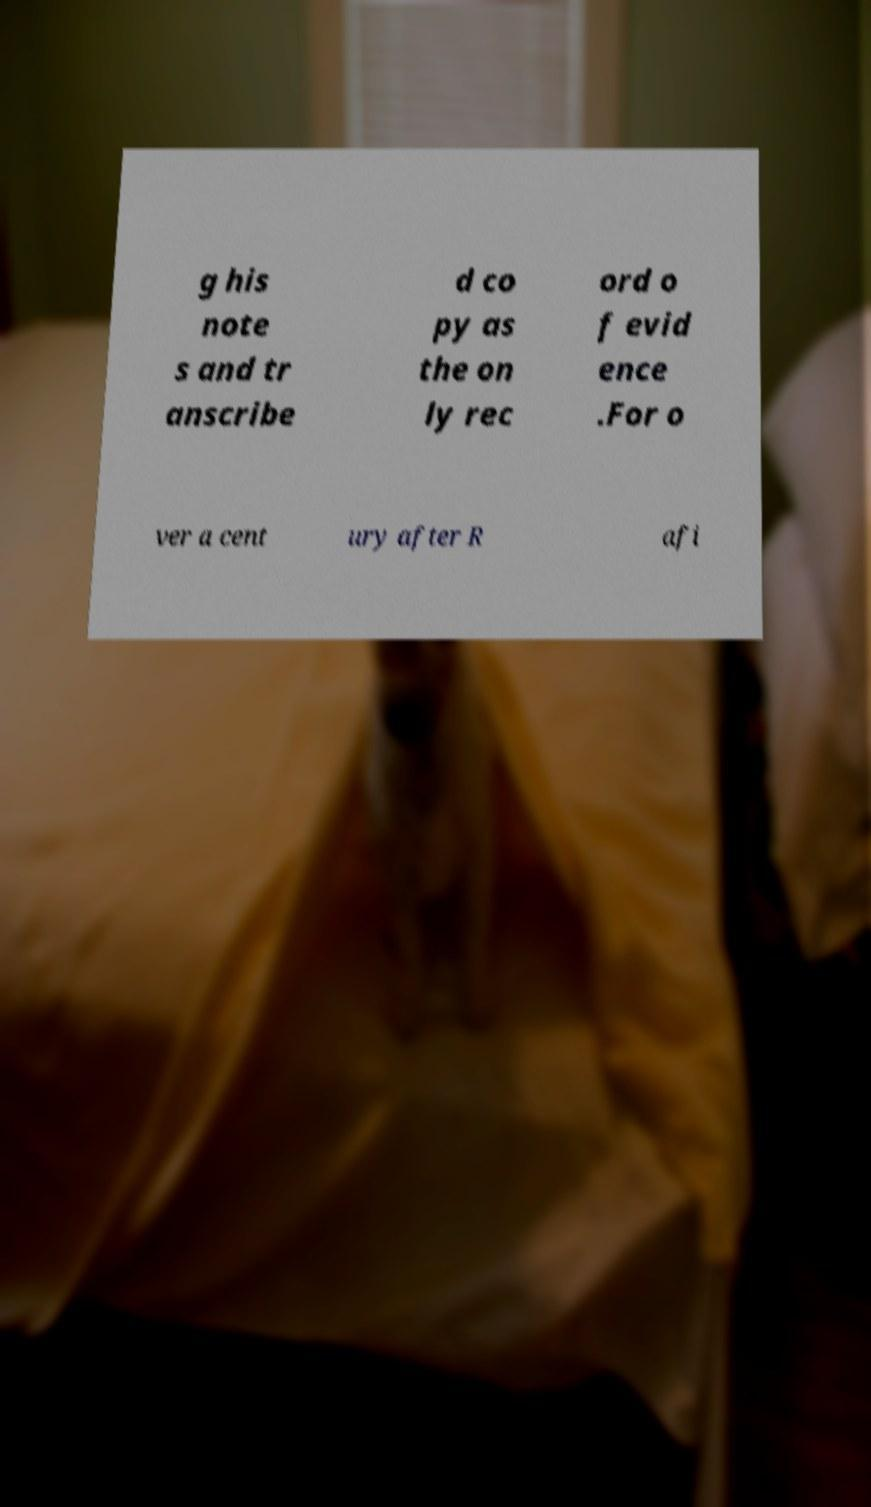Please identify and transcribe the text found in this image. g his note s and tr anscribe d co py as the on ly rec ord o f evid ence .For o ver a cent ury after R afi 